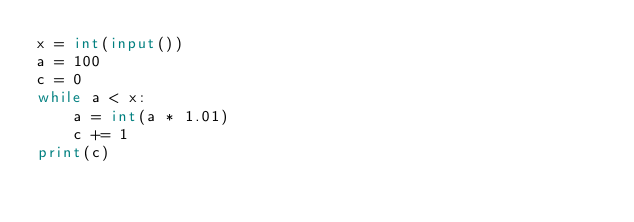<code> <loc_0><loc_0><loc_500><loc_500><_Python_>x = int(input())
a = 100
c = 0
while a < x:
    a = int(a * 1.01)
    c += 1
print(c)
</code> 